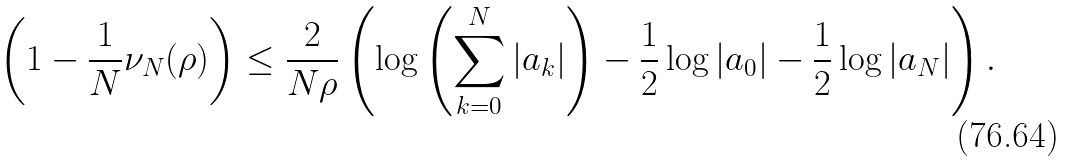Convert formula to latex. <formula><loc_0><loc_0><loc_500><loc_500>\left ( 1 - \frac { 1 } { N } \nu _ { N } ( \rho ) \right ) \leq \frac { 2 } { N \rho } \left ( \log \left ( \sum _ { k = 0 } ^ { N } | a _ { k } | \right ) - \frac { 1 } { 2 } \log | a _ { 0 } | - \frac { 1 } { 2 } \log | a _ { N } | \right ) .</formula> 